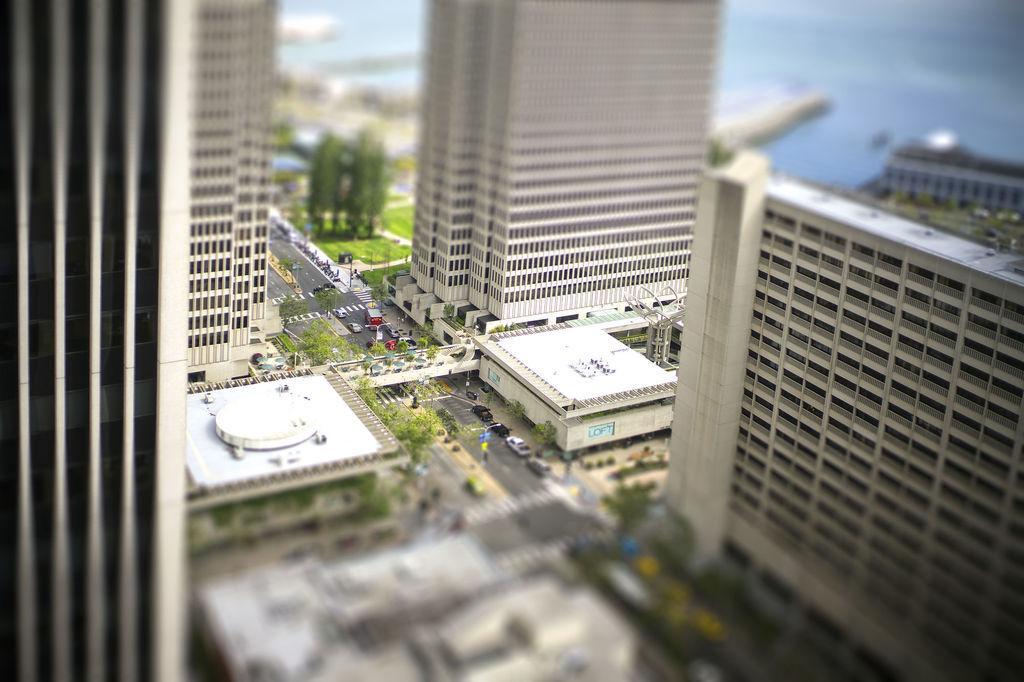Please provide a concise description of this image. In the center of the image we can see buildings, trees, vehicles on the road, poles, one banner, one bridge, grass and a few other objects. 